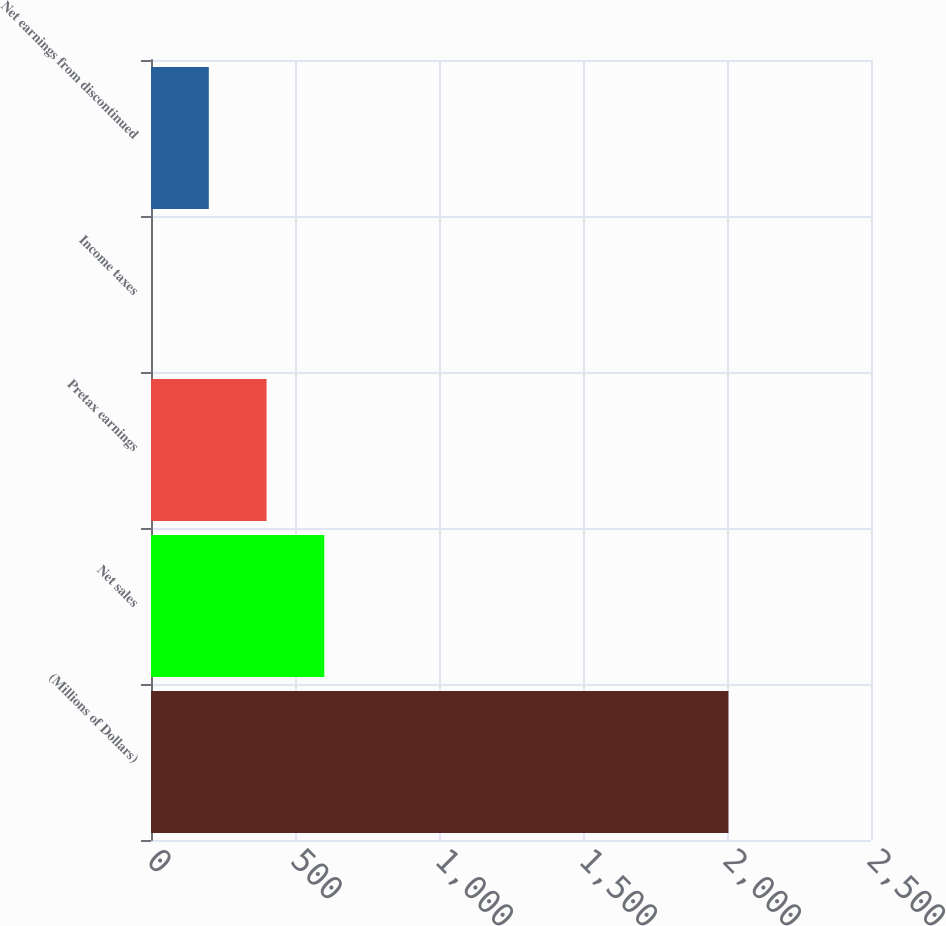Convert chart to OTSL. <chart><loc_0><loc_0><loc_500><loc_500><bar_chart><fcel>(Millions of Dollars)<fcel>Net sales<fcel>Pretax earnings<fcel>Income taxes<fcel>Net earnings from discontinued<nl><fcel>2005<fcel>601.71<fcel>401.24<fcel>0.3<fcel>200.77<nl></chart> 